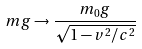<formula> <loc_0><loc_0><loc_500><loc_500>m g \rightarrow \frac { m _ { 0 } g } { \sqrt { 1 - v ^ { 2 } / c ^ { 2 } } }</formula> 